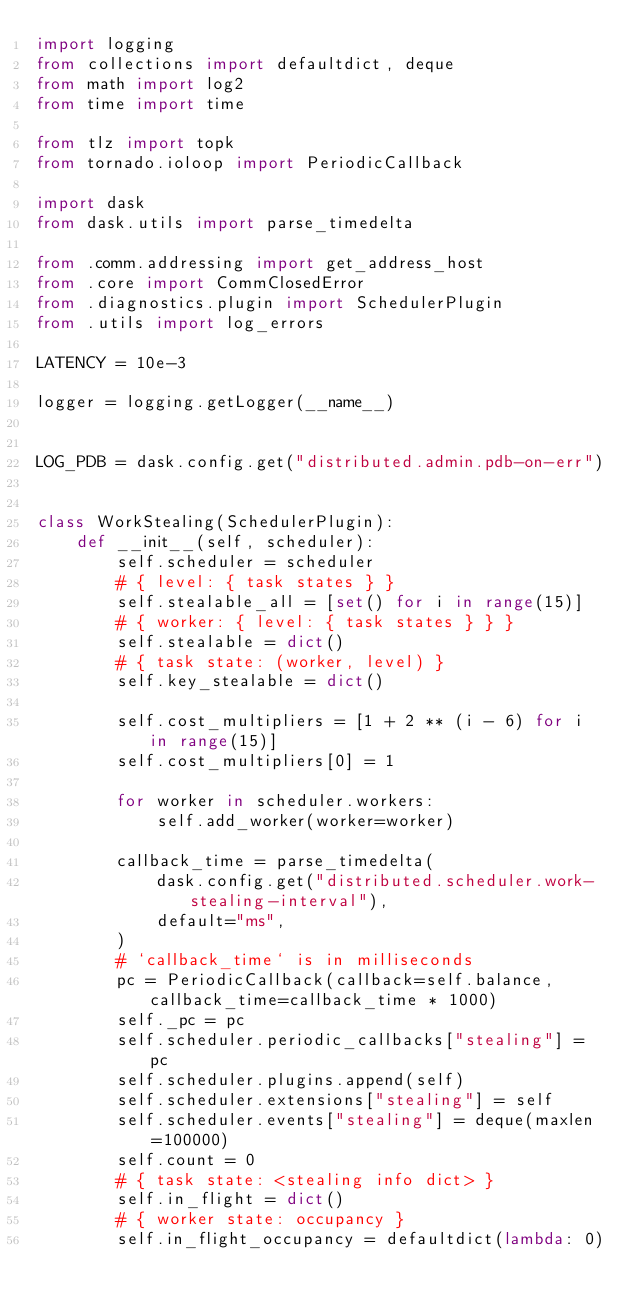<code> <loc_0><loc_0><loc_500><loc_500><_Python_>import logging
from collections import defaultdict, deque
from math import log2
from time import time

from tlz import topk
from tornado.ioloop import PeriodicCallback

import dask
from dask.utils import parse_timedelta

from .comm.addressing import get_address_host
from .core import CommClosedError
from .diagnostics.plugin import SchedulerPlugin
from .utils import log_errors

LATENCY = 10e-3

logger = logging.getLogger(__name__)


LOG_PDB = dask.config.get("distributed.admin.pdb-on-err")


class WorkStealing(SchedulerPlugin):
    def __init__(self, scheduler):
        self.scheduler = scheduler
        # { level: { task states } }
        self.stealable_all = [set() for i in range(15)]
        # { worker: { level: { task states } } }
        self.stealable = dict()
        # { task state: (worker, level) }
        self.key_stealable = dict()

        self.cost_multipliers = [1 + 2 ** (i - 6) for i in range(15)]
        self.cost_multipliers[0] = 1

        for worker in scheduler.workers:
            self.add_worker(worker=worker)

        callback_time = parse_timedelta(
            dask.config.get("distributed.scheduler.work-stealing-interval"),
            default="ms",
        )
        # `callback_time` is in milliseconds
        pc = PeriodicCallback(callback=self.balance, callback_time=callback_time * 1000)
        self._pc = pc
        self.scheduler.periodic_callbacks["stealing"] = pc
        self.scheduler.plugins.append(self)
        self.scheduler.extensions["stealing"] = self
        self.scheduler.events["stealing"] = deque(maxlen=100000)
        self.count = 0
        # { task state: <stealing info dict> }
        self.in_flight = dict()
        # { worker state: occupancy }
        self.in_flight_occupancy = defaultdict(lambda: 0)
</code> 